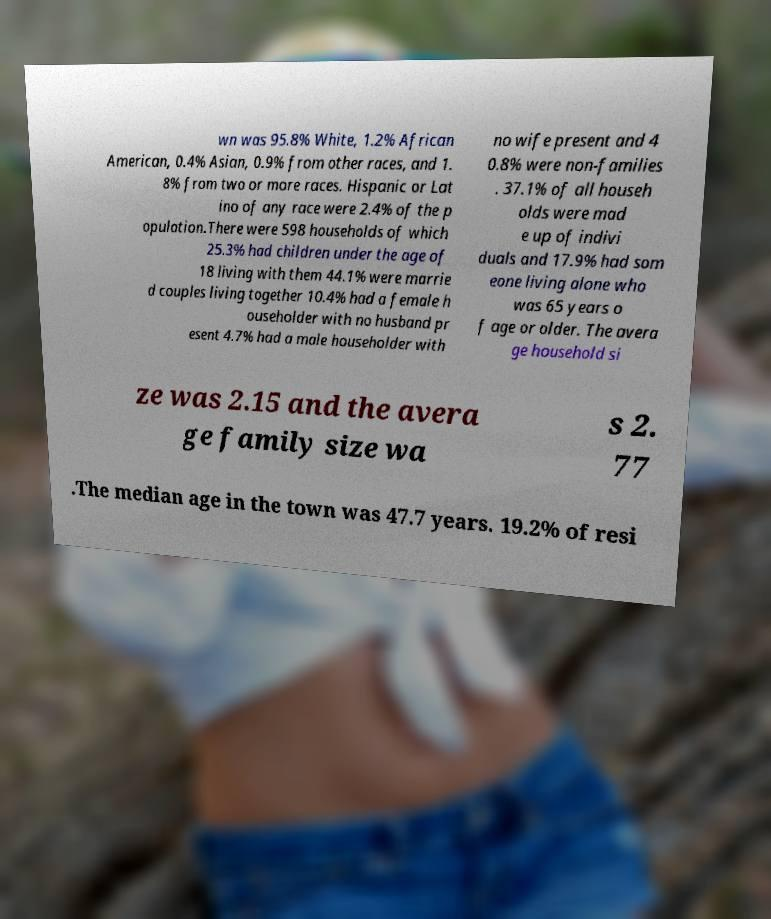Please identify and transcribe the text found in this image. wn was 95.8% White, 1.2% African American, 0.4% Asian, 0.9% from other races, and 1. 8% from two or more races. Hispanic or Lat ino of any race were 2.4% of the p opulation.There were 598 households of which 25.3% had children under the age of 18 living with them 44.1% were marrie d couples living together 10.4% had a female h ouseholder with no husband pr esent 4.7% had a male householder with no wife present and 4 0.8% were non-families . 37.1% of all househ olds were mad e up of indivi duals and 17.9% had som eone living alone who was 65 years o f age or older. The avera ge household si ze was 2.15 and the avera ge family size wa s 2. 77 .The median age in the town was 47.7 years. 19.2% of resi 